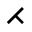<formula> <loc_0><loc_0><loc_500><loc_500>\right t h r e e t i m e s</formula> 